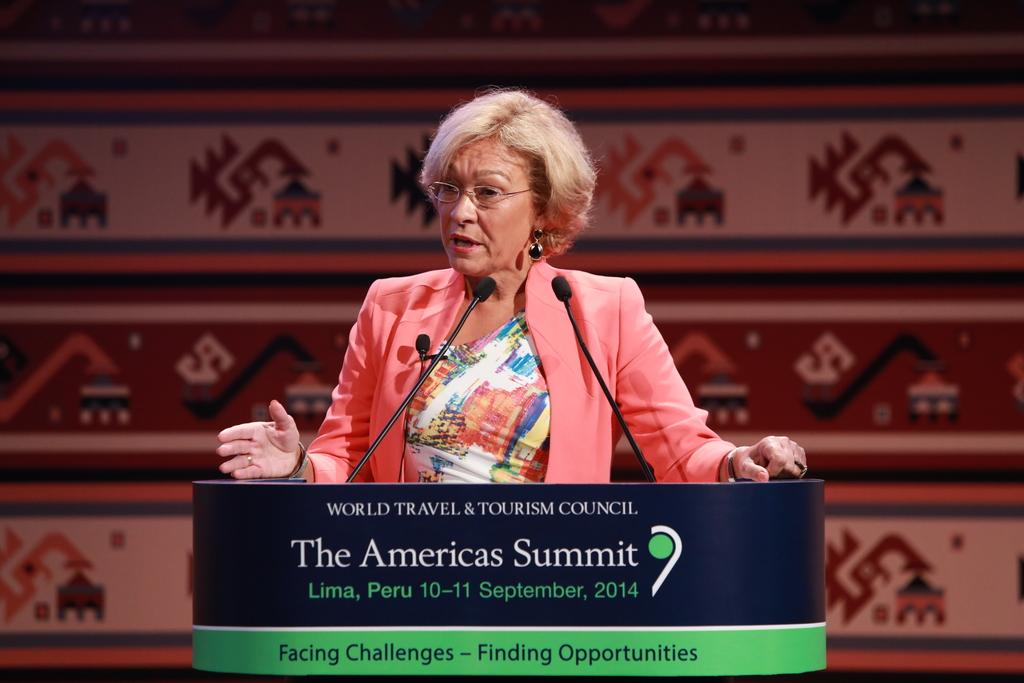Who is the main subject in the image? There is a woman in the image. What is the woman wearing? The woman is wearing spectacles. What is the woman doing in the image? The woman is standing at a podium and speaking on a microphone. How many dimes can be seen on the podium in the image? There are no dimes visible on the podium in the image. What color is the woman's attempt to speak in the image? The woman's attempt to speak is not a color; it is an action. 